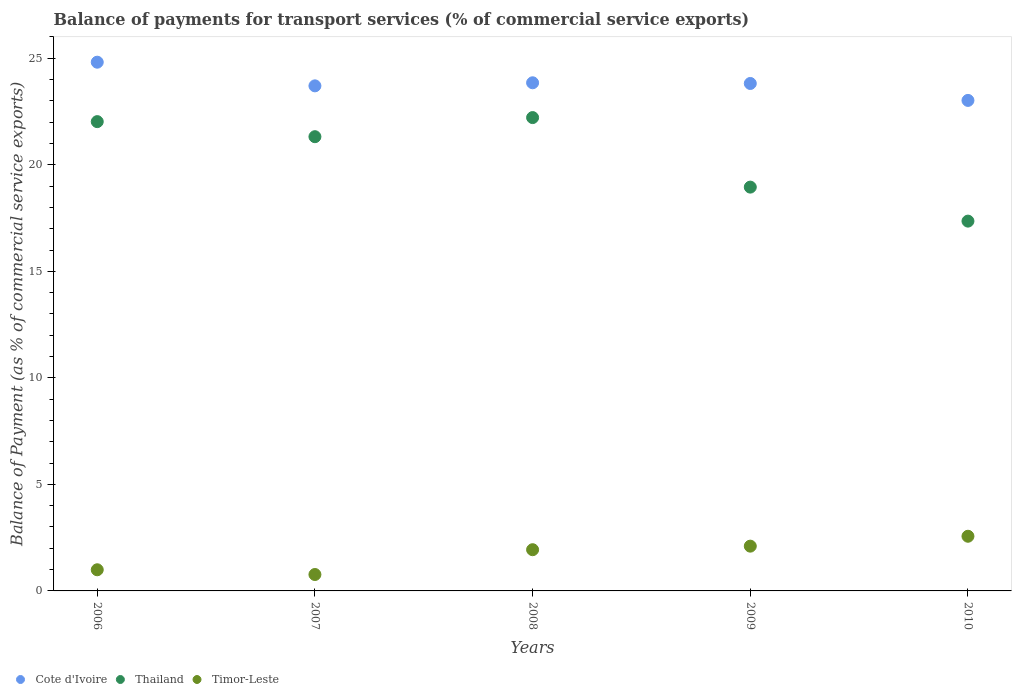What is the balance of payments for transport services in Thailand in 2008?
Your answer should be compact. 22.21. Across all years, what is the maximum balance of payments for transport services in Timor-Leste?
Make the answer very short. 2.57. Across all years, what is the minimum balance of payments for transport services in Thailand?
Your answer should be very brief. 17.36. In which year was the balance of payments for transport services in Thailand minimum?
Offer a very short reply. 2010. What is the total balance of payments for transport services in Thailand in the graph?
Ensure brevity in your answer.  101.86. What is the difference between the balance of payments for transport services in Thailand in 2006 and that in 2009?
Provide a succinct answer. 3.07. What is the difference between the balance of payments for transport services in Cote d'Ivoire in 2006 and the balance of payments for transport services in Timor-Leste in 2008?
Your answer should be compact. 22.88. What is the average balance of payments for transport services in Timor-Leste per year?
Provide a short and direct response. 1.67. In the year 2008, what is the difference between the balance of payments for transport services in Timor-Leste and balance of payments for transport services in Thailand?
Provide a succinct answer. -20.28. In how many years, is the balance of payments for transport services in Cote d'Ivoire greater than 20 %?
Provide a succinct answer. 5. What is the ratio of the balance of payments for transport services in Timor-Leste in 2007 to that in 2009?
Offer a terse response. 0.37. Is the balance of payments for transport services in Cote d'Ivoire in 2008 less than that in 2009?
Offer a terse response. No. Is the difference between the balance of payments for transport services in Timor-Leste in 2006 and 2008 greater than the difference between the balance of payments for transport services in Thailand in 2006 and 2008?
Provide a succinct answer. No. What is the difference between the highest and the second highest balance of payments for transport services in Timor-Leste?
Offer a very short reply. 0.46. What is the difference between the highest and the lowest balance of payments for transport services in Timor-Leste?
Your answer should be very brief. 1.8. In how many years, is the balance of payments for transport services in Thailand greater than the average balance of payments for transport services in Thailand taken over all years?
Provide a short and direct response. 3. How many years are there in the graph?
Ensure brevity in your answer.  5. What is the difference between two consecutive major ticks on the Y-axis?
Ensure brevity in your answer.  5. Does the graph contain grids?
Make the answer very short. No. Where does the legend appear in the graph?
Provide a succinct answer. Bottom left. How many legend labels are there?
Give a very brief answer. 3. How are the legend labels stacked?
Your response must be concise. Horizontal. What is the title of the graph?
Your answer should be compact. Balance of payments for transport services (% of commercial service exports). Does "Kiribati" appear as one of the legend labels in the graph?
Offer a terse response. No. What is the label or title of the Y-axis?
Keep it short and to the point. Balance of Payment (as % of commercial service exports). What is the Balance of Payment (as % of commercial service exports) of Cote d'Ivoire in 2006?
Your response must be concise. 24.81. What is the Balance of Payment (as % of commercial service exports) in Thailand in 2006?
Provide a succinct answer. 22.03. What is the Balance of Payment (as % of commercial service exports) in Timor-Leste in 2006?
Provide a succinct answer. 0.99. What is the Balance of Payment (as % of commercial service exports) in Cote d'Ivoire in 2007?
Your answer should be very brief. 23.7. What is the Balance of Payment (as % of commercial service exports) in Thailand in 2007?
Provide a succinct answer. 21.32. What is the Balance of Payment (as % of commercial service exports) of Timor-Leste in 2007?
Your answer should be very brief. 0.77. What is the Balance of Payment (as % of commercial service exports) in Cote d'Ivoire in 2008?
Provide a succinct answer. 23.85. What is the Balance of Payment (as % of commercial service exports) in Thailand in 2008?
Keep it short and to the point. 22.21. What is the Balance of Payment (as % of commercial service exports) of Timor-Leste in 2008?
Give a very brief answer. 1.93. What is the Balance of Payment (as % of commercial service exports) in Cote d'Ivoire in 2009?
Ensure brevity in your answer.  23.82. What is the Balance of Payment (as % of commercial service exports) of Thailand in 2009?
Your answer should be compact. 18.95. What is the Balance of Payment (as % of commercial service exports) in Timor-Leste in 2009?
Ensure brevity in your answer.  2.1. What is the Balance of Payment (as % of commercial service exports) in Cote d'Ivoire in 2010?
Keep it short and to the point. 23.02. What is the Balance of Payment (as % of commercial service exports) of Thailand in 2010?
Offer a very short reply. 17.36. What is the Balance of Payment (as % of commercial service exports) of Timor-Leste in 2010?
Provide a succinct answer. 2.57. Across all years, what is the maximum Balance of Payment (as % of commercial service exports) in Cote d'Ivoire?
Offer a very short reply. 24.81. Across all years, what is the maximum Balance of Payment (as % of commercial service exports) of Thailand?
Keep it short and to the point. 22.21. Across all years, what is the maximum Balance of Payment (as % of commercial service exports) in Timor-Leste?
Offer a terse response. 2.57. Across all years, what is the minimum Balance of Payment (as % of commercial service exports) of Cote d'Ivoire?
Offer a terse response. 23.02. Across all years, what is the minimum Balance of Payment (as % of commercial service exports) of Thailand?
Make the answer very short. 17.36. Across all years, what is the minimum Balance of Payment (as % of commercial service exports) of Timor-Leste?
Ensure brevity in your answer.  0.77. What is the total Balance of Payment (as % of commercial service exports) in Cote d'Ivoire in the graph?
Ensure brevity in your answer.  119.2. What is the total Balance of Payment (as % of commercial service exports) of Thailand in the graph?
Provide a short and direct response. 101.86. What is the total Balance of Payment (as % of commercial service exports) in Timor-Leste in the graph?
Offer a very short reply. 8.36. What is the difference between the Balance of Payment (as % of commercial service exports) in Cote d'Ivoire in 2006 and that in 2007?
Make the answer very short. 1.11. What is the difference between the Balance of Payment (as % of commercial service exports) in Thailand in 2006 and that in 2007?
Your answer should be compact. 0.71. What is the difference between the Balance of Payment (as % of commercial service exports) in Timor-Leste in 2006 and that in 2007?
Your answer should be very brief. 0.22. What is the difference between the Balance of Payment (as % of commercial service exports) in Cote d'Ivoire in 2006 and that in 2008?
Offer a very short reply. 0.97. What is the difference between the Balance of Payment (as % of commercial service exports) in Thailand in 2006 and that in 2008?
Offer a terse response. -0.19. What is the difference between the Balance of Payment (as % of commercial service exports) of Timor-Leste in 2006 and that in 2008?
Your response must be concise. -0.94. What is the difference between the Balance of Payment (as % of commercial service exports) of Thailand in 2006 and that in 2009?
Provide a succinct answer. 3.07. What is the difference between the Balance of Payment (as % of commercial service exports) of Timor-Leste in 2006 and that in 2009?
Ensure brevity in your answer.  -1.11. What is the difference between the Balance of Payment (as % of commercial service exports) of Cote d'Ivoire in 2006 and that in 2010?
Offer a terse response. 1.79. What is the difference between the Balance of Payment (as % of commercial service exports) in Thailand in 2006 and that in 2010?
Keep it short and to the point. 4.67. What is the difference between the Balance of Payment (as % of commercial service exports) in Timor-Leste in 2006 and that in 2010?
Provide a succinct answer. -1.57. What is the difference between the Balance of Payment (as % of commercial service exports) in Cote d'Ivoire in 2007 and that in 2008?
Your response must be concise. -0.14. What is the difference between the Balance of Payment (as % of commercial service exports) of Thailand in 2007 and that in 2008?
Ensure brevity in your answer.  -0.9. What is the difference between the Balance of Payment (as % of commercial service exports) in Timor-Leste in 2007 and that in 2008?
Ensure brevity in your answer.  -1.16. What is the difference between the Balance of Payment (as % of commercial service exports) of Cote d'Ivoire in 2007 and that in 2009?
Your response must be concise. -0.11. What is the difference between the Balance of Payment (as % of commercial service exports) in Thailand in 2007 and that in 2009?
Your response must be concise. 2.37. What is the difference between the Balance of Payment (as % of commercial service exports) of Timor-Leste in 2007 and that in 2009?
Offer a very short reply. -1.33. What is the difference between the Balance of Payment (as % of commercial service exports) of Cote d'Ivoire in 2007 and that in 2010?
Your answer should be compact. 0.68. What is the difference between the Balance of Payment (as % of commercial service exports) in Thailand in 2007 and that in 2010?
Ensure brevity in your answer.  3.96. What is the difference between the Balance of Payment (as % of commercial service exports) in Timor-Leste in 2007 and that in 2010?
Your answer should be compact. -1.8. What is the difference between the Balance of Payment (as % of commercial service exports) of Cote d'Ivoire in 2008 and that in 2009?
Offer a very short reply. 0.03. What is the difference between the Balance of Payment (as % of commercial service exports) in Thailand in 2008 and that in 2009?
Ensure brevity in your answer.  3.26. What is the difference between the Balance of Payment (as % of commercial service exports) of Timor-Leste in 2008 and that in 2009?
Provide a succinct answer. -0.17. What is the difference between the Balance of Payment (as % of commercial service exports) of Cote d'Ivoire in 2008 and that in 2010?
Offer a very short reply. 0.83. What is the difference between the Balance of Payment (as % of commercial service exports) of Thailand in 2008 and that in 2010?
Ensure brevity in your answer.  4.86. What is the difference between the Balance of Payment (as % of commercial service exports) in Timor-Leste in 2008 and that in 2010?
Keep it short and to the point. -0.63. What is the difference between the Balance of Payment (as % of commercial service exports) in Cote d'Ivoire in 2009 and that in 2010?
Your answer should be very brief. 0.79. What is the difference between the Balance of Payment (as % of commercial service exports) of Thailand in 2009 and that in 2010?
Your answer should be compact. 1.6. What is the difference between the Balance of Payment (as % of commercial service exports) in Timor-Leste in 2009 and that in 2010?
Make the answer very short. -0.46. What is the difference between the Balance of Payment (as % of commercial service exports) in Cote d'Ivoire in 2006 and the Balance of Payment (as % of commercial service exports) in Thailand in 2007?
Offer a very short reply. 3.5. What is the difference between the Balance of Payment (as % of commercial service exports) of Cote d'Ivoire in 2006 and the Balance of Payment (as % of commercial service exports) of Timor-Leste in 2007?
Offer a very short reply. 24.04. What is the difference between the Balance of Payment (as % of commercial service exports) of Thailand in 2006 and the Balance of Payment (as % of commercial service exports) of Timor-Leste in 2007?
Provide a short and direct response. 21.25. What is the difference between the Balance of Payment (as % of commercial service exports) in Cote d'Ivoire in 2006 and the Balance of Payment (as % of commercial service exports) in Thailand in 2008?
Keep it short and to the point. 2.6. What is the difference between the Balance of Payment (as % of commercial service exports) in Cote d'Ivoire in 2006 and the Balance of Payment (as % of commercial service exports) in Timor-Leste in 2008?
Ensure brevity in your answer.  22.88. What is the difference between the Balance of Payment (as % of commercial service exports) in Thailand in 2006 and the Balance of Payment (as % of commercial service exports) in Timor-Leste in 2008?
Give a very brief answer. 20.09. What is the difference between the Balance of Payment (as % of commercial service exports) of Cote d'Ivoire in 2006 and the Balance of Payment (as % of commercial service exports) of Thailand in 2009?
Your answer should be compact. 5.86. What is the difference between the Balance of Payment (as % of commercial service exports) of Cote d'Ivoire in 2006 and the Balance of Payment (as % of commercial service exports) of Timor-Leste in 2009?
Keep it short and to the point. 22.71. What is the difference between the Balance of Payment (as % of commercial service exports) of Thailand in 2006 and the Balance of Payment (as % of commercial service exports) of Timor-Leste in 2009?
Offer a terse response. 19.92. What is the difference between the Balance of Payment (as % of commercial service exports) of Cote d'Ivoire in 2006 and the Balance of Payment (as % of commercial service exports) of Thailand in 2010?
Your response must be concise. 7.46. What is the difference between the Balance of Payment (as % of commercial service exports) of Cote d'Ivoire in 2006 and the Balance of Payment (as % of commercial service exports) of Timor-Leste in 2010?
Your response must be concise. 22.25. What is the difference between the Balance of Payment (as % of commercial service exports) of Thailand in 2006 and the Balance of Payment (as % of commercial service exports) of Timor-Leste in 2010?
Offer a terse response. 19.46. What is the difference between the Balance of Payment (as % of commercial service exports) in Cote d'Ivoire in 2007 and the Balance of Payment (as % of commercial service exports) in Thailand in 2008?
Your response must be concise. 1.49. What is the difference between the Balance of Payment (as % of commercial service exports) of Cote d'Ivoire in 2007 and the Balance of Payment (as % of commercial service exports) of Timor-Leste in 2008?
Your response must be concise. 21.77. What is the difference between the Balance of Payment (as % of commercial service exports) of Thailand in 2007 and the Balance of Payment (as % of commercial service exports) of Timor-Leste in 2008?
Provide a succinct answer. 19.38. What is the difference between the Balance of Payment (as % of commercial service exports) of Cote d'Ivoire in 2007 and the Balance of Payment (as % of commercial service exports) of Thailand in 2009?
Keep it short and to the point. 4.75. What is the difference between the Balance of Payment (as % of commercial service exports) of Cote d'Ivoire in 2007 and the Balance of Payment (as % of commercial service exports) of Timor-Leste in 2009?
Your response must be concise. 21.6. What is the difference between the Balance of Payment (as % of commercial service exports) of Thailand in 2007 and the Balance of Payment (as % of commercial service exports) of Timor-Leste in 2009?
Provide a succinct answer. 19.22. What is the difference between the Balance of Payment (as % of commercial service exports) of Cote d'Ivoire in 2007 and the Balance of Payment (as % of commercial service exports) of Thailand in 2010?
Offer a very short reply. 6.35. What is the difference between the Balance of Payment (as % of commercial service exports) of Cote d'Ivoire in 2007 and the Balance of Payment (as % of commercial service exports) of Timor-Leste in 2010?
Make the answer very short. 21.14. What is the difference between the Balance of Payment (as % of commercial service exports) of Thailand in 2007 and the Balance of Payment (as % of commercial service exports) of Timor-Leste in 2010?
Provide a short and direct response. 18.75. What is the difference between the Balance of Payment (as % of commercial service exports) in Cote d'Ivoire in 2008 and the Balance of Payment (as % of commercial service exports) in Thailand in 2009?
Provide a short and direct response. 4.9. What is the difference between the Balance of Payment (as % of commercial service exports) in Cote d'Ivoire in 2008 and the Balance of Payment (as % of commercial service exports) in Timor-Leste in 2009?
Offer a terse response. 21.75. What is the difference between the Balance of Payment (as % of commercial service exports) of Thailand in 2008 and the Balance of Payment (as % of commercial service exports) of Timor-Leste in 2009?
Your answer should be compact. 20.11. What is the difference between the Balance of Payment (as % of commercial service exports) of Cote d'Ivoire in 2008 and the Balance of Payment (as % of commercial service exports) of Thailand in 2010?
Ensure brevity in your answer.  6.49. What is the difference between the Balance of Payment (as % of commercial service exports) in Cote d'Ivoire in 2008 and the Balance of Payment (as % of commercial service exports) in Timor-Leste in 2010?
Make the answer very short. 21.28. What is the difference between the Balance of Payment (as % of commercial service exports) of Thailand in 2008 and the Balance of Payment (as % of commercial service exports) of Timor-Leste in 2010?
Provide a succinct answer. 19.65. What is the difference between the Balance of Payment (as % of commercial service exports) in Cote d'Ivoire in 2009 and the Balance of Payment (as % of commercial service exports) in Thailand in 2010?
Offer a very short reply. 6.46. What is the difference between the Balance of Payment (as % of commercial service exports) of Cote d'Ivoire in 2009 and the Balance of Payment (as % of commercial service exports) of Timor-Leste in 2010?
Provide a succinct answer. 21.25. What is the difference between the Balance of Payment (as % of commercial service exports) in Thailand in 2009 and the Balance of Payment (as % of commercial service exports) in Timor-Leste in 2010?
Provide a succinct answer. 16.39. What is the average Balance of Payment (as % of commercial service exports) of Cote d'Ivoire per year?
Offer a very short reply. 23.84. What is the average Balance of Payment (as % of commercial service exports) in Thailand per year?
Your answer should be compact. 20.37. What is the average Balance of Payment (as % of commercial service exports) of Timor-Leste per year?
Offer a terse response. 1.67. In the year 2006, what is the difference between the Balance of Payment (as % of commercial service exports) of Cote d'Ivoire and Balance of Payment (as % of commercial service exports) of Thailand?
Offer a very short reply. 2.79. In the year 2006, what is the difference between the Balance of Payment (as % of commercial service exports) in Cote d'Ivoire and Balance of Payment (as % of commercial service exports) in Timor-Leste?
Make the answer very short. 23.82. In the year 2006, what is the difference between the Balance of Payment (as % of commercial service exports) in Thailand and Balance of Payment (as % of commercial service exports) in Timor-Leste?
Provide a short and direct response. 21.03. In the year 2007, what is the difference between the Balance of Payment (as % of commercial service exports) of Cote d'Ivoire and Balance of Payment (as % of commercial service exports) of Thailand?
Your answer should be compact. 2.39. In the year 2007, what is the difference between the Balance of Payment (as % of commercial service exports) in Cote d'Ivoire and Balance of Payment (as % of commercial service exports) in Timor-Leste?
Provide a succinct answer. 22.93. In the year 2007, what is the difference between the Balance of Payment (as % of commercial service exports) of Thailand and Balance of Payment (as % of commercial service exports) of Timor-Leste?
Give a very brief answer. 20.55. In the year 2008, what is the difference between the Balance of Payment (as % of commercial service exports) of Cote d'Ivoire and Balance of Payment (as % of commercial service exports) of Thailand?
Provide a short and direct response. 1.63. In the year 2008, what is the difference between the Balance of Payment (as % of commercial service exports) in Cote d'Ivoire and Balance of Payment (as % of commercial service exports) in Timor-Leste?
Keep it short and to the point. 21.91. In the year 2008, what is the difference between the Balance of Payment (as % of commercial service exports) in Thailand and Balance of Payment (as % of commercial service exports) in Timor-Leste?
Keep it short and to the point. 20.28. In the year 2009, what is the difference between the Balance of Payment (as % of commercial service exports) in Cote d'Ivoire and Balance of Payment (as % of commercial service exports) in Thailand?
Ensure brevity in your answer.  4.86. In the year 2009, what is the difference between the Balance of Payment (as % of commercial service exports) in Cote d'Ivoire and Balance of Payment (as % of commercial service exports) in Timor-Leste?
Offer a terse response. 21.71. In the year 2009, what is the difference between the Balance of Payment (as % of commercial service exports) in Thailand and Balance of Payment (as % of commercial service exports) in Timor-Leste?
Ensure brevity in your answer.  16.85. In the year 2010, what is the difference between the Balance of Payment (as % of commercial service exports) in Cote d'Ivoire and Balance of Payment (as % of commercial service exports) in Thailand?
Your answer should be very brief. 5.67. In the year 2010, what is the difference between the Balance of Payment (as % of commercial service exports) in Cote d'Ivoire and Balance of Payment (as % of commercial service exports) in Timor-Leste?
Your response must be concise. 20.45. In the year 2010, what is the difference between the Balance of Payment (as % of commercial service exports) in Thailand and Balance of Payment (as % of commercial service exports) in Timor-Leste?
Provide a short and direct response. 14.79. What is the ratio of the Balance of Payment (as % of commercial service exports) of Cote d'Ivoire in 2006 to that in 2007?
Provide a succinct answer. 1.05. What is the ratio of the Balance of Payment (as % of commercial service exports) of Thailand in 2006 to that in 2007?
Give a very brief answer. 1.03. What is the ratio of the Balance of Payment (as % of commercial service exports) in Timor-Leste in 2006 to that in 2007?
Give a very brief answer. 1.29. What is the ratio of the Balance of Payment (as % of commercial service exports) in Cote d'Ivoire in 2006 to that in 2008?
Your answer should be very brief. 1.04. What is the ratio of the Balance of Payment (as % of commercial service exports) in Timor-Leste in 2006 to that in 2008?
Your answer should be compact. 0.51. What is the ratio of the Balance of Payment (as % of commercial service exports) in Cote d'Ivoire in 2006 to that in 2009?
Keep it short and to the point. 1.04. What is the ratio of the Balance of Payment (as % of commercial service exports) in Thailand in 2006 to that in 2009?
Provide a succinct answer. 1.16. What is the ratio of the Balance of Payment (as % of commercial service exports) in Timor-Leste in 2006 to that in 2009?
Offer a very short reply. 0.47. What is the ratio of the Balance of Payment (as % of commercial service exports) in Cote d'Ivoire in 2006 to that in 2010?
Offer a terse response. 1.08. What is the ratio of the Balance of Payment (as % of commercial service exports) of Thailand in 2006 to that in 2010?
Keep it short and to the point. 1.27. What is the ratio of the Balance of Payment (as % of commercial service exports) of Timor-Leste in 2006 to that in 2010?
Make the answer very short. 0.39. What is the ratio of the Balance of Payment (as % of commercial service exports) in Thailand in 2007 to that in 2008?
Your answer should be very brief. 0.96. What is the ratio of the Balance of Payment (as % of commercial service exports) of Timor-Leste in 2007 to that in 2008?
Offer a terse response. 0.4. What is the ratio of the Balance of Payment (as % of commercial service exports) of Thailand in 2007 to that in 2009?
Offer a terse response. 1.12. What is the ratio of the Balance of Payment (as % of commercial service exports) of Timor-Leste in 2007 to that in 2009?
Offer a terse response. 0.37. What is the ratio of the Balance of Payment (as % of commercial service exports) of Cote d'Ivoire in 2007 to that in 2010?
Your answer should be compact. 1.03. What is the ratio of the Balance of Payment (as % of commercial service exports) of Thailand in 2007 to that in 2010?
Your answer should be very brief. 1.23. What is the ratio of the Balance of Payment (as % of commercial service exports) of Timor-Leste in 2007 to that in 2010?
Your response must be concise. 0.3. What is the ratio of the Balance of Payment (as % of commercial service exports) in Cote d'Ivoire in 2008 to that in 2009?
Ensure brevity in your answer.  1. What is the ratio of the Balance of Payment (as % of commercial service exports) in Thailand in 2008 to that in 2009?
Keep it short and to the point. 1.17. What is the ratio of the Balance of Payment (as % of commercial service exports) of Timor-Leste in 2008 to that in 2009?
Make the answer very short. 0.92. What is the ratio of the Balance of Payment (as % of commercial service exports) in Cote d'Ivoire in 2008 to that in 2010?
Your answer should be compact. 1.04. What is the ratio of the Balance of Payment (as % of commercial service exports) in Thailand in 2008 to that in 2010?
Your answer should be compact. 1.28. What is the ratio of the Balance of Payment (as % of commercial service exports) of Timor-Leste in 2008 to that in 2010?
Keep it short and to the point. 0.75. What is the ratio of the Balance of Payment (as % of commercial service exports) in Cote d'Ivoire in 2009 to that in 2010?
Offer a very short reply. 1.03. What is the ratio of the Balance of Payment (as % of commercial service exports) of Thailand in 2009 to that in 2010?
Your answer should be compact. 1.09. What is the ratio of the Balance of Payment (as % of commercial service exports) of Timor-Leste in 2009 to that in 2010?
Your response must be concise. 0.82. What is the difference between the highest and the second highest Balance of Payment (as % of commercial service exports) in Cote d'Ivoire?
Ensure brevity in your answer.  0.97. What is the difference between the highest and the second highest Balance of Payment (as % of commercial service exports) in Thailand?
Your answer should be very brief. 0.19. What is the difference between the highest and the second highest Balance of Payment (as % of commercial service exports) in Timor-Leste?
Your response must be concise. 0.46. What is the difference between the highest and the lowest Balance of Payment (as % of commercial service exports) of Cote d'Ivoire?
Your answer should be very brief. 1.79. What is the difference between the highest and the lowest Balance of Payment (as % of commercial service exports) in Thailand?
Your answer should be compact. 4.86. What is the difference between the highest and the lowest Balance of Payment (as % of commercial service exports) of Timor-Leste?
Your answer should be very brief. 1.8. 